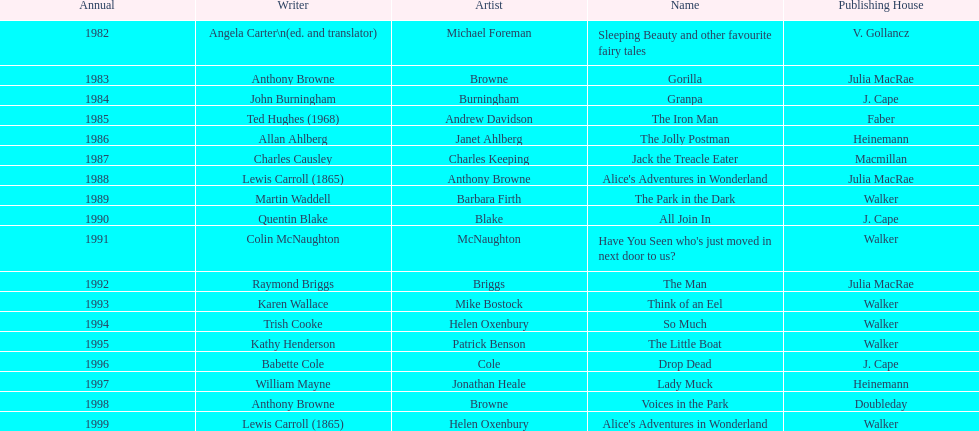Which book won the award a total of 2 times? Alice's Adventures in Wonderland. 